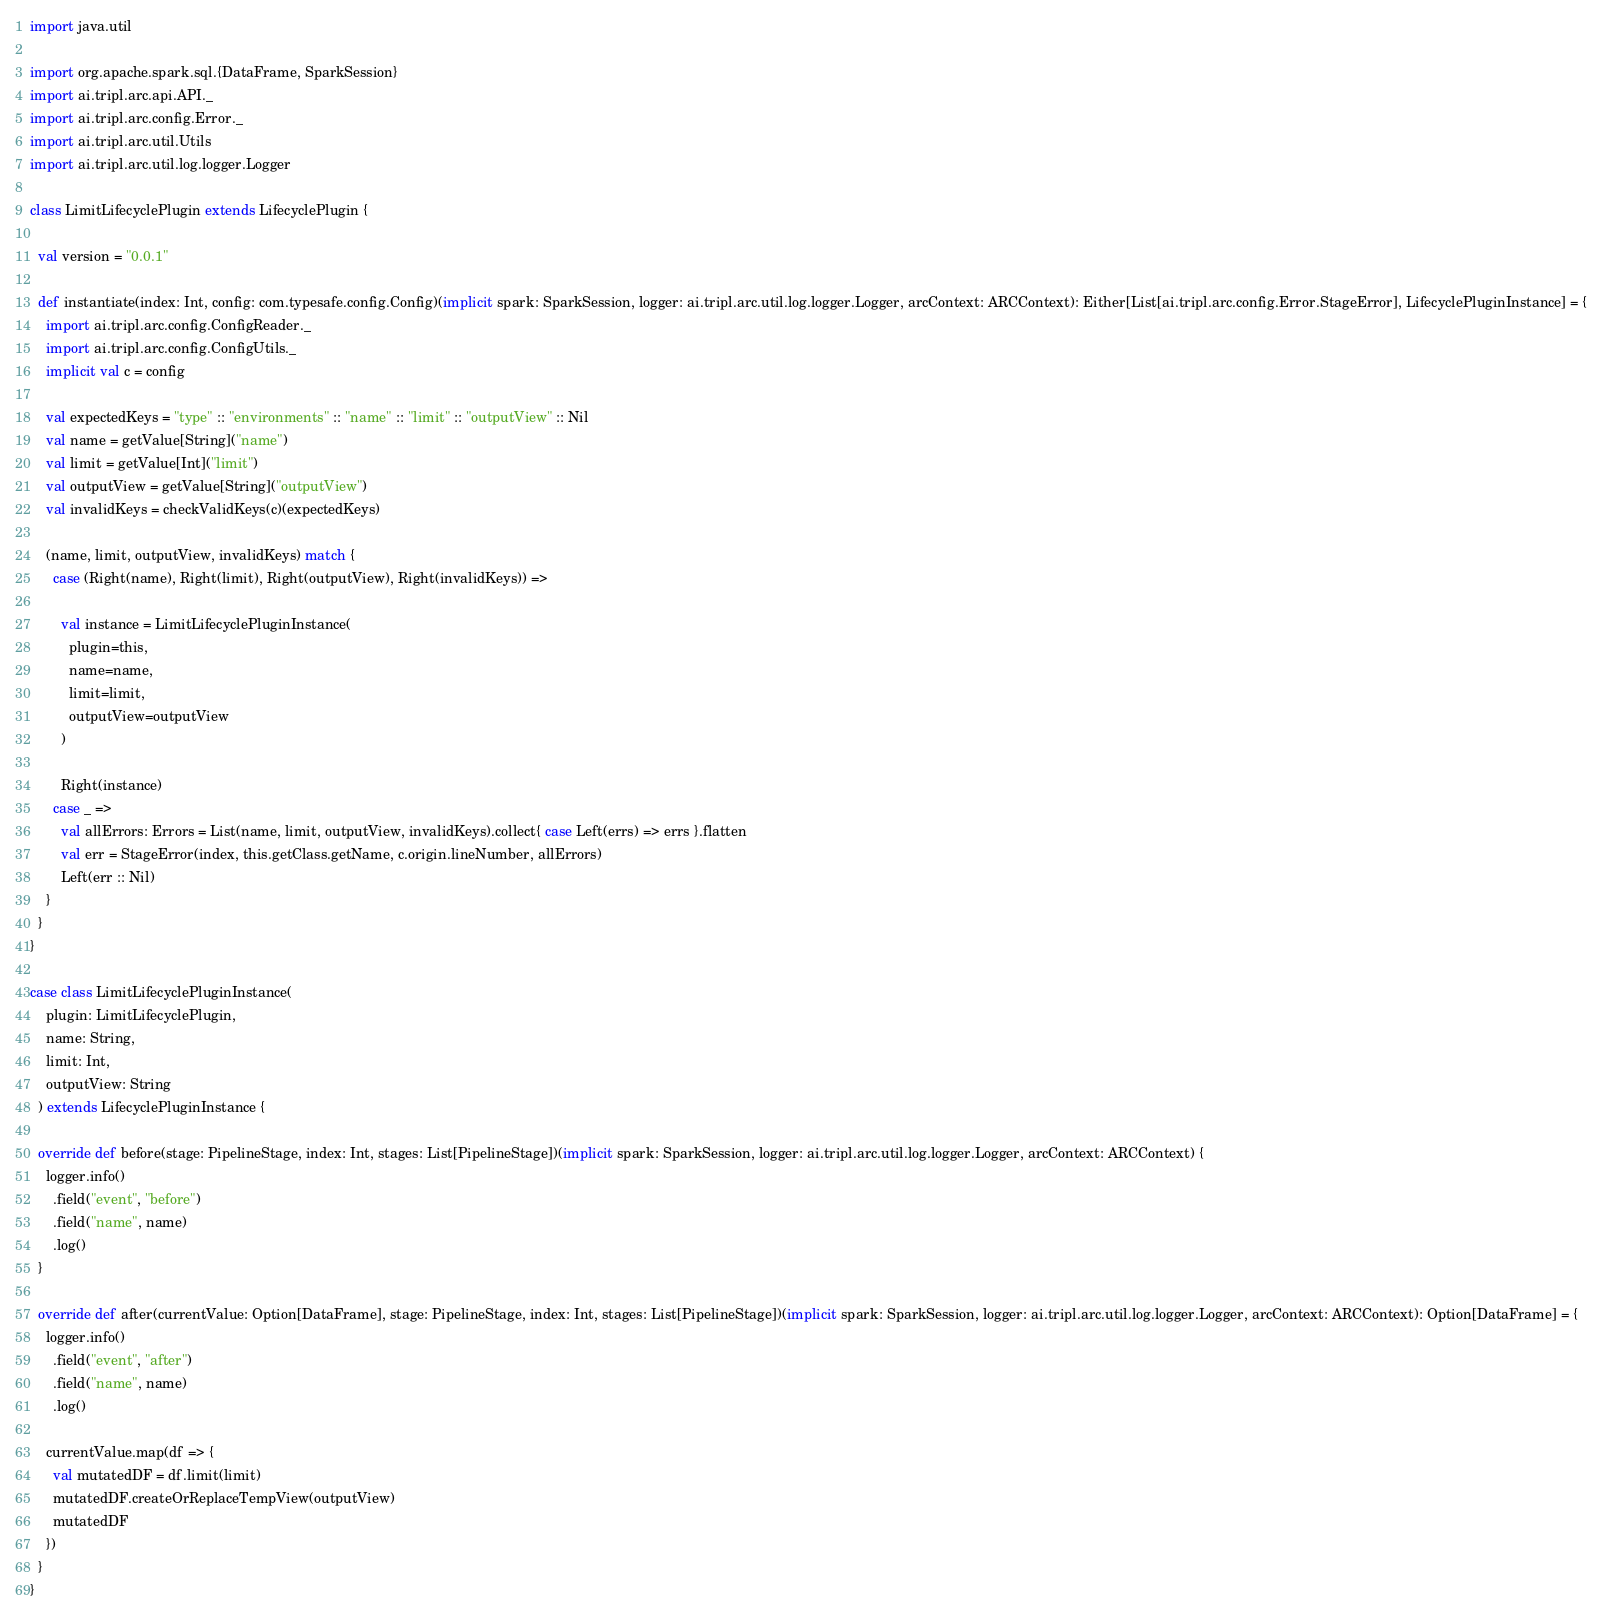<code> <loc_0><loc_0><loc_500><loc_500><_Scala_>import java.util

import org.apache.spark.sql.{DataFrame, SparkSession}
import ai.tripl.arc.api.API._
import ai.tripl.arc.config.Error._
import ai.tripl.arc.util.Utils
import ai.tripl.arc.util.log.logger.Logger

class LimitLifecyclePlugin extends LifecyclePlugin {

  val version = "0.0.1"

  def instantiate(index: Int, config: com.typesafe.config.Config)(implicit spark: SparkSession, logger: ai.tripl.arc.util.log.logger.Logger, arcContext: ARCContext): Either[List[ai.tripl.arc.config.Error.StageError], LifecyclePluginInstance] = {
    import ai.tripl.arc.config.ConfigReader._
    import ai.tripl.arc.config.ConfigUtils._
    implicit val c = config

    val expectedKeys = "type" :: "environments" :: "name" :: "limit" :: "outputView" :: Nil
    val name = getValue[String]("name")
    val limit = getValue[Int]("limit")
    val outputView = getValue[String]("outputView")
    val invalidKeys = checkValidKeys(c)(expectedKeys)

    (name, limit, outputView, invalidKeys) match {
      case (Right(name), Right(limit), Right(outputView), Right(invalidKeys)) =>

        val instance = LimitLifecyclePluginInstance(
          plugin=this,
          name=name,
          limit=limit,
          outputView=outputView
        )

        Right(instance)
      case _ =>
        val allErrors: Errors = List(name, limit, outputView, invalidKeys).collect{ case Left(errs) => errs }.flatten
        val err = StageError(index, this.getClass.getName, c.origin.lineNumber, allErrors)
        Left(err :: Nil)
    }
  }
}

case class LimitLifecyclePluginInstance(
    plugin: LimitLifecyclePlugin,
    name: String,
    limit: Int,
    outputView: String
  ) extends LifecyclePluginInstance {

  override def before(stage: PipelineStage, index: Int, stages: List[PipelineStage])(implicit spark: SparkSession, logger: ai.tripl.arc.util.log.logger.Logger, arcContext: ARCContext) {
    logger.info()
      .field("event", "before")
      .field("name", name)
      .log()
  }

  override def after(currentValue: Option[DataFrame], stage: PipelineStage, index: Int, stages: List[PipelineStage])(implicit spark: SparkSession, logger: ai.tripl.arc.util.log.logger.Logger, arcContext: ARCContext): Option[DataFrame] = {
    logger.info()
      .field("event", "after")
      .field("name", name)
      .log()

    currentValue.map(df => {
      val mutatedDF = df.limit(limit)
      mutatedDF.createOrReplaceTempView(outputView)
      mutatedDF
    })
  }
}</code> 